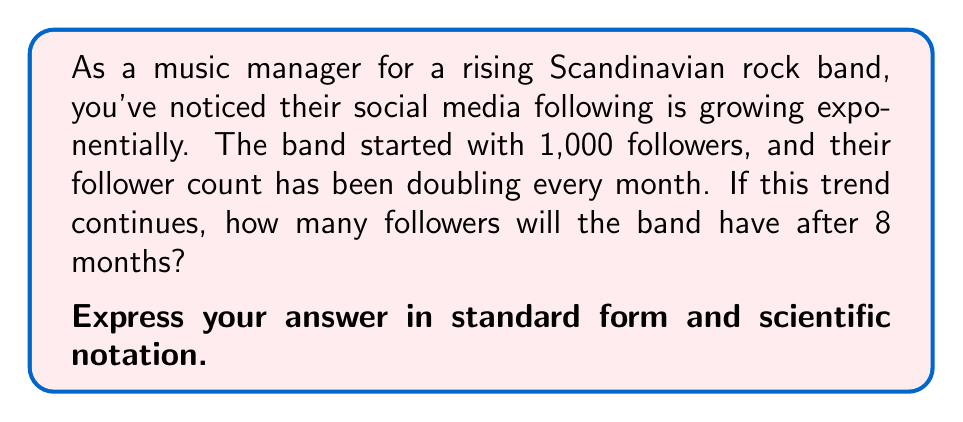Provide a solution to this math problem. Let's approach this step-by-step:

1) The initial number of followers is 1,000.

2) The growth rate is doubling (multiplying by 2) every month.

3) This can be expressed as an exponential function:

   $f(t) = 1000 \cdot 2^t$

   Where $f(t)$ is the number of followers after $t$ months.

4) We need to calculate this for $t = 8$ months:

   $f(8) = 1000 \cdot 2^8$

5) Let's calculate $2^8$:

   $2^8 = 2 \cdot 2 \cdot 2 \cdot 2 \cdot 2 \cdot 2 \cdot 2 \cdot 2 = 256$

6) Now we can complete the calculation:

   $f(8) = 1000 \cdot 256 = 256,000$

7) To express this in scientific notation:

   $256,000 = 2.56 \times 10^5$

Therefore, after 8 months, the band will have 256,000 followers.
Answer: 256,000 followers (standard form)
$2.56 \times 10^5$ followers (scientific notation) 